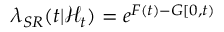<formula> <loc_0><loc_0><loc_500><loc_500>\lambda _ { S R } ( t | \mathcal { H } _ { t } ) = e ^ { F ( t ) - G [ 0 , t ) }</formula> 